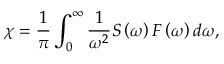<formula> <loc_0><loc_0><loc_500><loc_500>\chi = \frac { 1 } { \pi } \int _ { 0 } ^ { \infty } \frac { 1 } { \omega ^ { 2 } } S \left ( \omega \right ) F \left ( \omega \right ) d \omega ,</formula> 